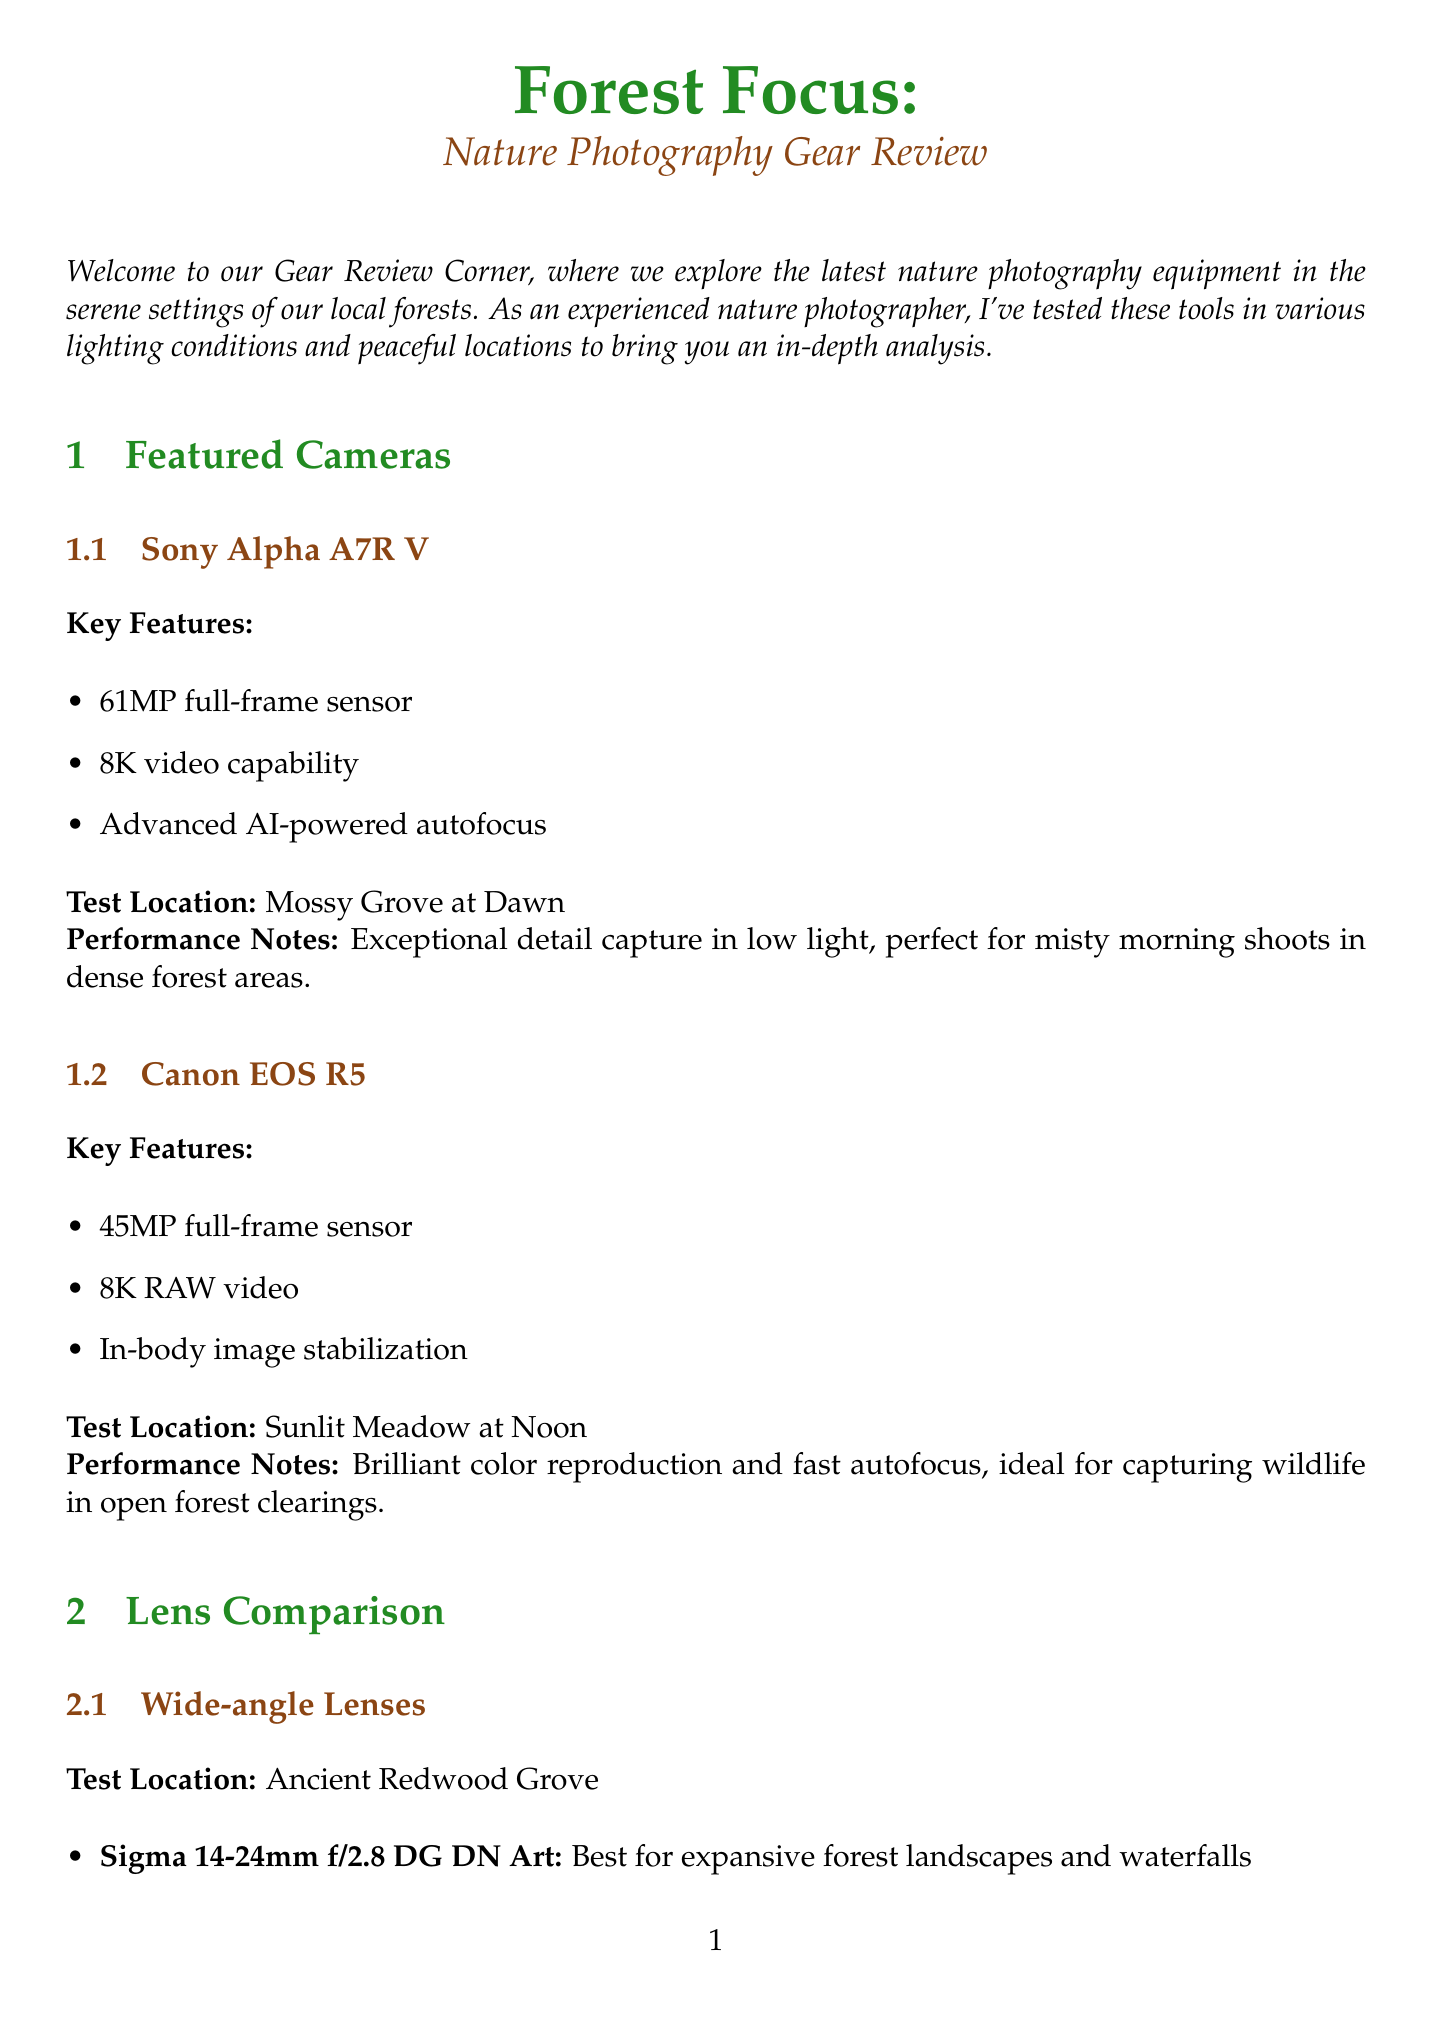What is the title of the newsletter? The title is presented at the beginning of the document.
Answer: Forest Focus: Nature Photography Gear Review Who tested the photography equipment? The introduction mentions the person responsible for testing the equipment.
Answer: an experienced nature photographer What type of sensor does the Sony Alpha A7R V have? This information is listed in the key features section for the camera.
Answer: 61MP full-frame sensor Which lens is best for lightweight forest shooting? This is detailed in the lens comparison section under its best use case.
Answer: Tamron 17-28mm f/2.8 Di III RXD What was the test location for the tripod? The performance descriptions for the tripod detail where it was tested.
Answer: Rocky stream bed for long exposure shots What feature enhances foliage colors in the accessory spotlight? The benefits of the circular polarizer highlight this specific feature.
Answer: Enhances foliage colors Which camera is ideal for open forest clearings? The performance notes for this camera indicate its suitability for a specific environment.
Answer: Canon EOS R5 How many key features does the Peak Design Travel Tripod have? The tripod section lists its key features in bullet points.
Answer: 3 What is recommended to minimize camera shake in low light conditions? This advice is provided in the photographer tips section.
Answer: Use a remote shutter release 